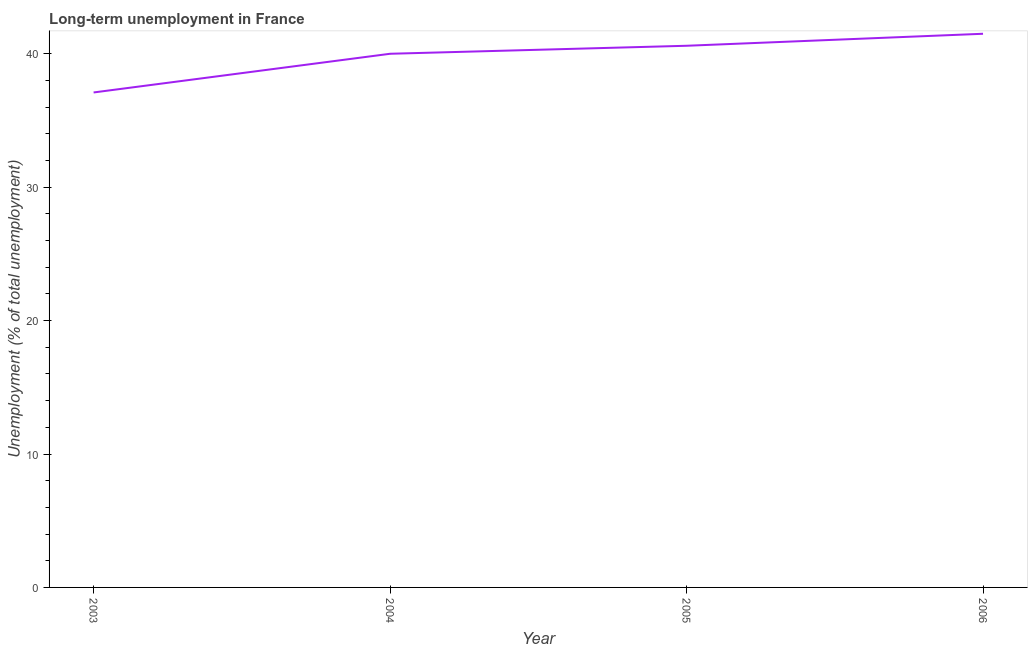What is the long-term unemployment in 2006?
Your answer should be very brief. 41.5. Across all years, what is the maximum long-term unemployment?
Offer a terse response. 41.5. Across all years, what is the minimum long-term unemployment?
Make the answer very short. 37.1. In which year was the long-term unemployment maximum?
Your response must be concise. 2006. What is the sum of the long-term unemployment?
Your response must be concise. 159.2. What is the difference between the long-term unemployment in 2003 and 2006?
Provide a short and direct response. -4.4. What is the average long-term unemployment per year?
Your answer should be compact. 39.8. What is the median long-term unemployment?
Your response must be concise. 40.3. In how many years, is the long-term unemployment greater than 38 %?
Your answer should be compact. 3. What is the ratio of the long-term unemployment in 2003 to that in 2004?
Your response must be concise. 0.93. What is the difference between the highest and the second highest long-term unemployment?
Give a very brief answer. 0.9. What is the difference between the highest and the lowest long-term unemployment?
Offer a terse response. 4.4. In how many years, is the long-term unemployment greater than the average long-term unemployment taken over all years?
Give a very brief answer. 3. Does the long-term unemployment monotonically increase over the years?
Provide a short and direct response. Yes. How many lines are there?
Make the answer very short. 1. Are the values on the major ticks of Y-axis written in scientific E-notation?
Your answer should be very brief. No. Does the graph contain grids?
Your answer should be compact. No. What is the title of the graph?
Make the answer very short. Long-term unemployment in France. What is the label or title of the Y-axis?
Keep it short and to the point. Unemployment (% of total unemployment). What is the Unemployment (% of total unemployment) of 2003?
Make the answer very short. 37.1. What is the Unemployment (% of total unemployment) of 2004?
Your answer should be compact. 40. What is the Unemployment (% of total unemployment) of 2005?
Your answer should be compact. 40.6. What is the Unemployment (% of total unemployment) of 2006?
Provide a succinct answer. 41.5. What is the difference between the Unemployment (% of total unemployment) in 2003 and 2004?
Your response must be concise. -2.9. What is the difference between the Unemployment (% of total unemployment) in 2003 and 2006?
Make the answer very short. -4.4. What is the difference between the Unemployment (% of total unemployment) in 2004 and 2005?
Provide a succinct answer. -0.6. What is the difference between the Unemployment (% of total unemployment) in 2004 and 2006?
Ensure brevity in your answer.  -1.5. What is the ratio of the Unemployment (% of total unemployment) in 2003 to that in 2004?
Your answer should be compact. 0.93. What is the ratio of the Unemployment (% of total unemployment) in 2003 to that in 2005?
Provide a short and direct response. 0.91. What is the ratio of the Unemployment (% of total unemployment) in 2003 to that in 2006?
Your response must be concise. 0.89. What is the ratio of the Unemployment (% of total unemployment) in 2004 to that in 2005?
Your answer should be compact. 0.98. What is the ratio of the Unemployment (% of total unemployment) in 2005 to that in 2006?
Offer a very short reply. 0.98. 